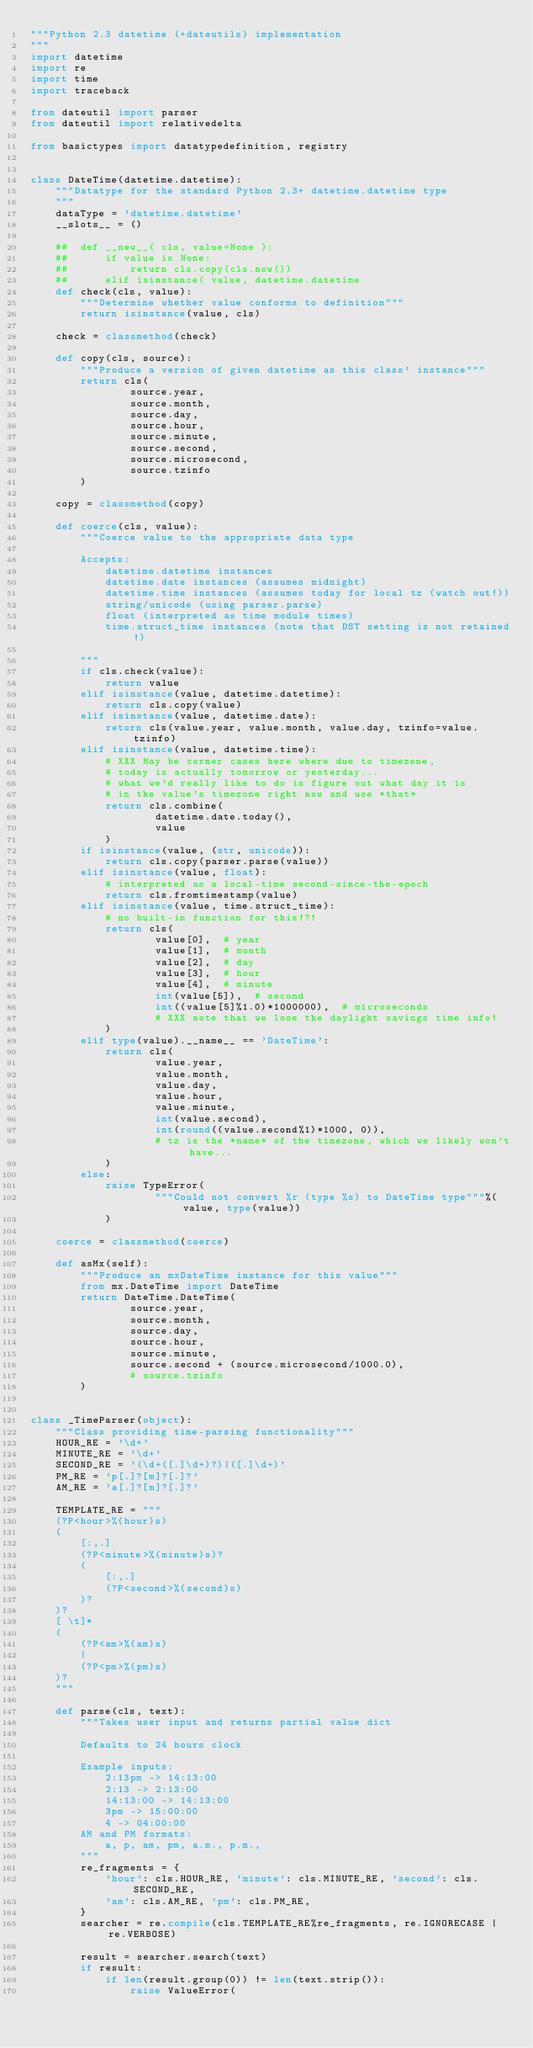Convert code to text. <code><loc_0><loc_0><loc_500><loc_500><_Python_>"""Python 2.3 datetime (+dateutils) implementation
"""
import datetime
import re
import time
import traceback

from dateutil import parser
from dateutil import relativedelta

from basictypes import datatypedefinition, registry


class DateTime(datetime.datetime):
    """Datatype for the standard Python 2.3+ datetime.datetime type
    """
    dataType = 'datetime.datetime'
    __slots__ = ()

    ##	def __new__( cls, value=None ):
    ##		if value is None:
    ##			return cls.copy(cls.now())
    ##		elif isinstance( value, datetime.datetime
    def check(cls, value):
        """Determine whether value conforms to definition"""
        return isinstance(value, cls)

    check = classmethod(check)

    def copy(cls, source):
        """Produce a version of given datetime as this class' instance"""
        return cls(
                source.year,
                source.month,
                source.day,
                source.hour,
                source.minute,
                source.second,
                source.microsecond,
                source.tzinfo
        )

    copy = classmethod(copy)

    def coerce(cls, value):
        """Coerce value to the appropriate data type

        Accepts:
            datetime.datetime instances
            datetime.date instances (assumes midnight)
            datetime.time instances (assumes today for local tz (watch out!))
            string/unicode (using parser.parse)
            float (interpreted as time module times)
            time.struct_time instances (note that DST setting is not retained!)

        """
        if cls.check(value):
            return value
        elif isinstance(value, datetime.datetime):
            return cls.copy(value)
        elif isinstance(value, datetime.date):
            return cls(value.year, value.month, value.day, tzinfo=value.tzinfo)
        elif isinstance(value, datetime.time):
            # XXX May be corner cases here where due to timezone,
            # today is actually tomorrow or yesterday...
            # what we'd really like to do is figure out what day it is
            # in the value's timezone right now and use *that*
            return cls.combine(
                    datetime.date.today(),
                    value
            )
        if isinstance(value, (str, unicode)):
            return cls.copy(parser.parse(value))
        elif isinstance(value, float):
            # interpreted as a local-time second-since-the-epoch
            return cls.fromtimestamp(value)
        elif isinstance(value, time.struct_time):
            # no built-in function for this!?!
            return cls(
                    value[0],  # year
                    value[1],  # month
                    value[2],  # day
                    value[3],  # hour
                    value[4],  # minute
                    int(value[5]),  # second
                    int((value[5]%1.0)*1000000),  # microseconds
                    # XXX note that we lose the daylight savings time info!
            )
        elif type(value).__name__ == 'DateTime':
            return cls(
                    value.year,
                    value.month,
                    value.day,
                    value.hour,
                    value.minute,
                    int(value.second),
                    int(round((value.second%1)*1000, 0)),
                    # tz is the *name* of the timezone, which we likely won't have...
            )
        else:
            raise TypeError(
                    """Could not convert %r (type %s) to DateTime type"""%(value, type(value))
            )

    coerce = classmethod(coerce)

    def asMx(self):
        """Produce an mxDateTime instance for this value"""
        from mx.DateTime import DateTime
        return DateTime.DateTime(
                source.year,
                source.month,
                source.day,
                source.hour,
                source.minute,
                source.second + (source.microsecond/1000.0),
                # source.tzinfo
        )


class _TimeParser(object):
    """Class providing time-parsing functionality"""
    HOUR_RE = '\d+'
    MINUTE_RE = '\d+'
    SECOND_RE = '(\d+([.]\d+)?)|([.]\d+)'
    PM_RE = 'p[.]?[m]?[.]?'
    AM_RE = 'a[.]?[m]?[.]?'

    TEMPLATE_RE = """
	(?P<hour>%(hour)s)
	(
		[:,.]
		(?P<minute>%(minute)s)?
		(
			[:,.]
			(?P<second>%(second)s)
		)?
	)?
	[ \t]*
	(
		(?P<am>%(am)s)
		|
		(?P<pm>%(pm)s)
	)?
	"""

    def parse(cls, text):
        """Takes user input and returns partial value dict

        Defaults to 24 hours clock

        Example inputs:
            2:13pm -> 14:13:00
            2:13 -> 2:13:00
            14:13:00 -> 14:13:00
            3pm -> 15:00:00
            4 -> 04:00:00
        AM and PM formats:
            a, p, am, pm, a.m., p.m.,
        """
        re_fragments = {
            'hour': cls.HOUR_RE, 'minute': cls.MINUTE_RE, 'second': cls.SECOND_RE,
            'am': cls.AM_RE, 'pm': cls.PM_RE,
        }
        searcher = re.compile(cls.TEMPLATE_RE%re_fragments, re.IGNORECASE | re.VERBOSE)

        result = searcher.search(text)
        if result:
            if len(result.group(0)) != len(text.strip()):
                raise ValueError(</code> 